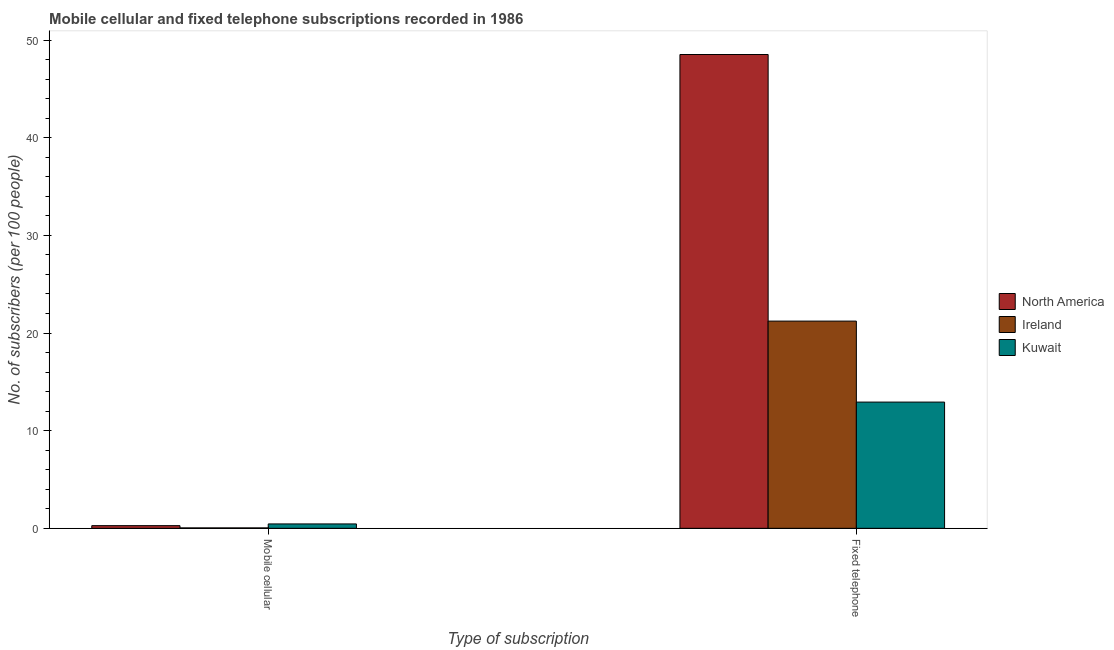How many different coloured bars are there?
Provide a short and direct response. 3. How many bars are there on the 2nd tick from the left?
Provide a short and direct response. 3. How many bars are there on the 2nd tick from the right?
Offer a terse response. 3. What is the label of the 2nd group of bars from the left?
Offer a terse response. Fixed telephone. What is the number of mobile cellular subscribers in North America?
Offer a very short reply. 0.27. Across all countries, what is the maximum number of fixed telephone subscribers?
Your answer should be very brief. 48.52. Across all countries, what is the minimum number of fixed telephone subscribers?
Provide a short and direct response. 12.93. In which country was the number of fixed telephone subscribers minimum?
Provide a short and direct response. Kuwait. What is the total number of mobile cellular subscribers in the graph?
Provide a short and direct response. 0.77. What is the difference between the number of mobile cellular subscribers in Kuwait and that in Ireland?
Offer a terse response. 0.41. What is the difference between the number of fixed telephone subscribers in Ireland and the number of mobile cellular subscribers in North America?
Provide a succinct answer. 20.94. What is the average number of fixed telephone subscribers per country?
Make the answer very short. 27.55. What is the difference between the number of fixed telephone subscribers and number of mobile cellular subscribers in Kuwait?
Your answer should be compact. 12.48. What is the ratio of the number of fixed telephone subscribers in North America to that in Ireland?
Provide a succinct answer. 2.29. In how many countries, is the number of mobile cellular subscribers greater than the average number of mobile cellular subscribers taken over all countries?
Offer a terse response. 2. What does the 2nd bar from the left in Fixed telephone represents?
Ensure brevity in your answer.  Ireland. How many bars are there?
Give a very brief answer. 6. Are all the bars in the graph horizontal?
Ensure brevity in your answer.  No. How many countries are there in the graph?
Offer a terse response. 3. Does the graph contain any zero values?
Offer a terse response. No. Does the graph contain grids?
Provide a short and direct response. No. Where does the legend appear in the graph?
Ensure brevity in your answer.  Center right. How many legend labels are there?
Give a very brief answer. 3. How are the legend labels stacked?
Keep it short and to the point. Vertical. What is the title of the graph?
Your response must be concise. Mobile cellular and fixed telephone subscriptions recorded in 1986. What is the label or title of the X-axis?
Offer a very short reply. Type of subscription. What is the label or title of the Y-axis?
Make the answer very short. No. of subscribers (per 100 people). What is the No. of subscribers (per 100 people) of North America in Mobile cellular?
Offer a very short reply. 0.27. What is the No. of subscribers (per 100 people) in Ireland in Mobile cellular?
Offer a terse response. 0.04. What is the No. of subscribers (per 100 people) in Kuwait in Mobile cellular?
Your answer should be very brief. 0.45. What is the No. of subscribers (per 100 people) in North America in Fixed telephone?
Make the answer very short. 48.52. What is the No. of subscribers (per 100 people) of Ireland in Fixed telephone?
Your answer should be very brief. 21.22. What is the No. of subscribers (per 100 people) of Kuwait in Fixed telephone?
Offer a terse response. 12.93. Across all Type of subscription, what is the maximum No. of subscribers (per 100 people) in North America?
Provide a succinct answer. 48.52. Across all Type of subscription, what is the maximum No. of subscribers (per 100 people) in Ireland?
Offer a terse response. 21.22. Across all Type of subscription, what is the maximum No. of subscribers (per 100 people) in Kuwait?
Make the answer very short. 12.93. Across all Type of subscription, what is the minimum No. of subscribers (per 100 people) of North America?
Offer a very short reply. 0.27. Across all Type of subscription, what is the minimum No. of subscribers (per 100 people) of Ireland?
Give a very brief answer. 0.04. Across all Type of subscription, what is the minimum No. of subscribers (per 100 people) of Kuwait?
Your answer should be compact. 0.45. What is the total No. of subscribers (per 100 people) of North America in the graph?
Offer a very short reply. 48.79. What is the total No. of subscribers (per 100 people) of Ireland in the graph?
Provide a short and direct response. 21.26. What is the total No. of subscribers (per 100 people) of Kuwait in the graph?
Offer a very short reply. 13.38. What is the difference between the No. of subscribers (per 100 people) in North America in Mobile cellular and that in Fixed telephone?
Your answer should be compact. -48.24. What is the difference between the No. of subscribers (per 100 people) in Ireland in Mobile cellular and that in Fixed telephone?
Your answer should be compact. -21.18. What is the difference between the No. of subscribers (per 100 people) in Kuwait in Mobile cellular and that in Fixed telephone?
Make the answer very short. -12.48. What is the difference between the No. of subscribers (per 100 people) of North America in Mobile cellular and the No. of subscribers (per 100 people) of Ireland in Fixed telephone?
Your response must be concise. -20.94. What is the difference between the No. of subscribers (per 100 people) of North America in Mobile cellular and the No. of subscribers (per 100 people) of Kuwait in Fixed telephone?
Provide a short and direct response. -12.65. What is the difference between the No. of subscribers (per 100 people) in Ireland in Mobile cellular and the No. of subscribers (per 100 people) in Kuwait in Fixed telephone?
Ensure brevity in your answer.  -12.88. What is the average No. of subscribers (per 100 people) in North America per Type of subscription?
Your answer should be very brief. 24.4. What is the average No. of subscribers (per 100 people) in Ireland per Type of subscription?
Ensure brevity in your answer.  10.63. What is the average No. of subscribers (per 100 people) of Kuwait per Type of subscription?
Give a very brief answer. 6.69. What is the difference between the No. of subscribers (per 100 people) in North America and No. of subscribers (per 100 people) in Ireland in Mobile cellular?
Offer a very short reply. 0.23. What is the difference between the No. of subscribers (per 100 people) of North America and No. of subscribers (per 100 people) of Kuwait in Mobile cellular?
Provide a succinct answer. -0.18. What is the difference between the No. of subscribers (per 100 people) of Ireland and No. of subscribers (per 100 people) of Kuwait in Mobile cellular?
Give a very brief answer. -0.41. What is the difference between the No. of subscribers (per 100 people) in North America and No. of subscribers (per 100 people) in Ireland in Fixed telephone?
Make the answer very short. 27.3. What is the difference between the No. of subscribers (per 100 people) in North America and No. of subscribers (per 100 people) in Kuwait in Fixed telephone?
Provide a short and direct response. 35.59. What is the difference between the No. of subscribers (per 100 people) of Ireland and No. of subscribers (per 100 people) of Kuwait in Fixed telephone?
Provide a succinct answer. 8.29. What is the ratio of the No. of subscribers (per 100 people) in North America in Mobile cellular to that in Fixed telephone?
Ensure brevity in your answer.  0.01. What is the ratio of the No. of subscribers (per 100 people) in Ireland in Mobile cellular to that in Fixed telephone?
Keep it short and to the point. 0. What is the ratio of the No. of subscribers (per 100 people) of Kuwait in Mobile cellular to that in Fixed telephone?
Your response must be concise. 0.03. What is the difference between the highest and the second highest No. of subscribers (per 100 people) of North America?
Make the answer very short. 48.24. What is the difference between the highest and the second highest No. of subscribers (per 100 people) in Ireland?
Provide a succinct answer. 21.18. What is the difference between the highest and the second highest No. of subscribers (per 100 people) of Kuwait?
Keep it short and to the point. 12.48. What is the difference between the highest and the lowest No. of subscribers (per 100 people) in North America?
Offer a very short reply. 48.24. What is the difference between the highest and the lowest No. of subscribers (per 100 people) in Ireland?
Keep it short and to the point. 21.18. What is the difference between the highest and the lowest No. of subscribers (per 100 people) of Kuwait?
Make the answer very short. 12.48. 